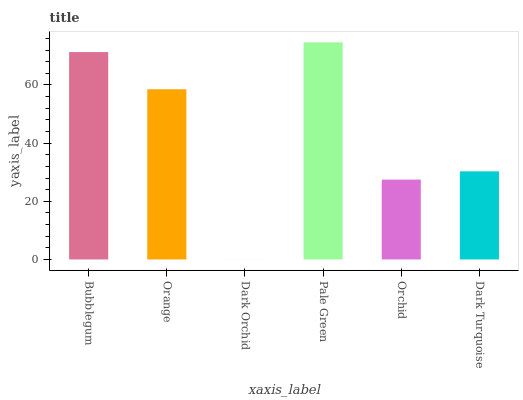Is Dark Orchid the minimum?
Answer yes or no. Yes. Is Pale Green the maximum?
Answer yes or no. Yes. Is Orange the minimum?
Answer yes or no. No. Is Orange the maximum?
Answer yes or no. No. Is Bubblegum greater than Orange?
Answer yes or no. Yes. Is Orange less than Bubblegum?
Answer yes or no. Yes. Is Orange greater than Bubblegum?
Answer yes or no. No. Is Bubblegum less than Orange?
Answer yes or no. No. Is Orange the high median?
Answer yes or no. Yes. Is Dark Turquoise the low median?
Answer yes or no. Yes. Is Orchid the high median?
Answer yes or no. No. Is Pale Green the low median?
Answer yes or no. No. 